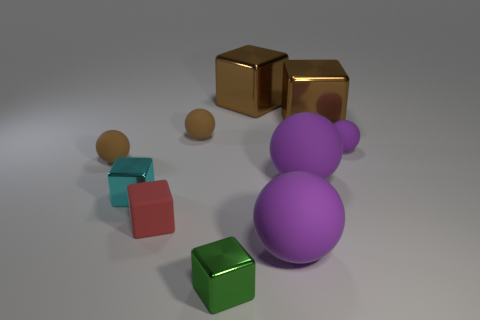Subtract all cyan cylinders. How many purple spheres are left? 3 Subtract all small purple matte spheres. How many spheres are left? 4 Subtract all red cubes. How many cubes are left? 4 Subtract 2 balls. How many balls are left? 3 Subtract all gray blocks. Subtract all cyan cylinders. How many blocks are left? 5 Subtract 0 purple cubes. How many objects are left? 10 Subtract all green things. Subtract all brown rubber spheres. How many objects are left? 7 Add 1 large brown blocks. How many large brown blocks are left? 3 Add 3 tiny green metal cubes. How many tiny green metal cubes exist? 4 